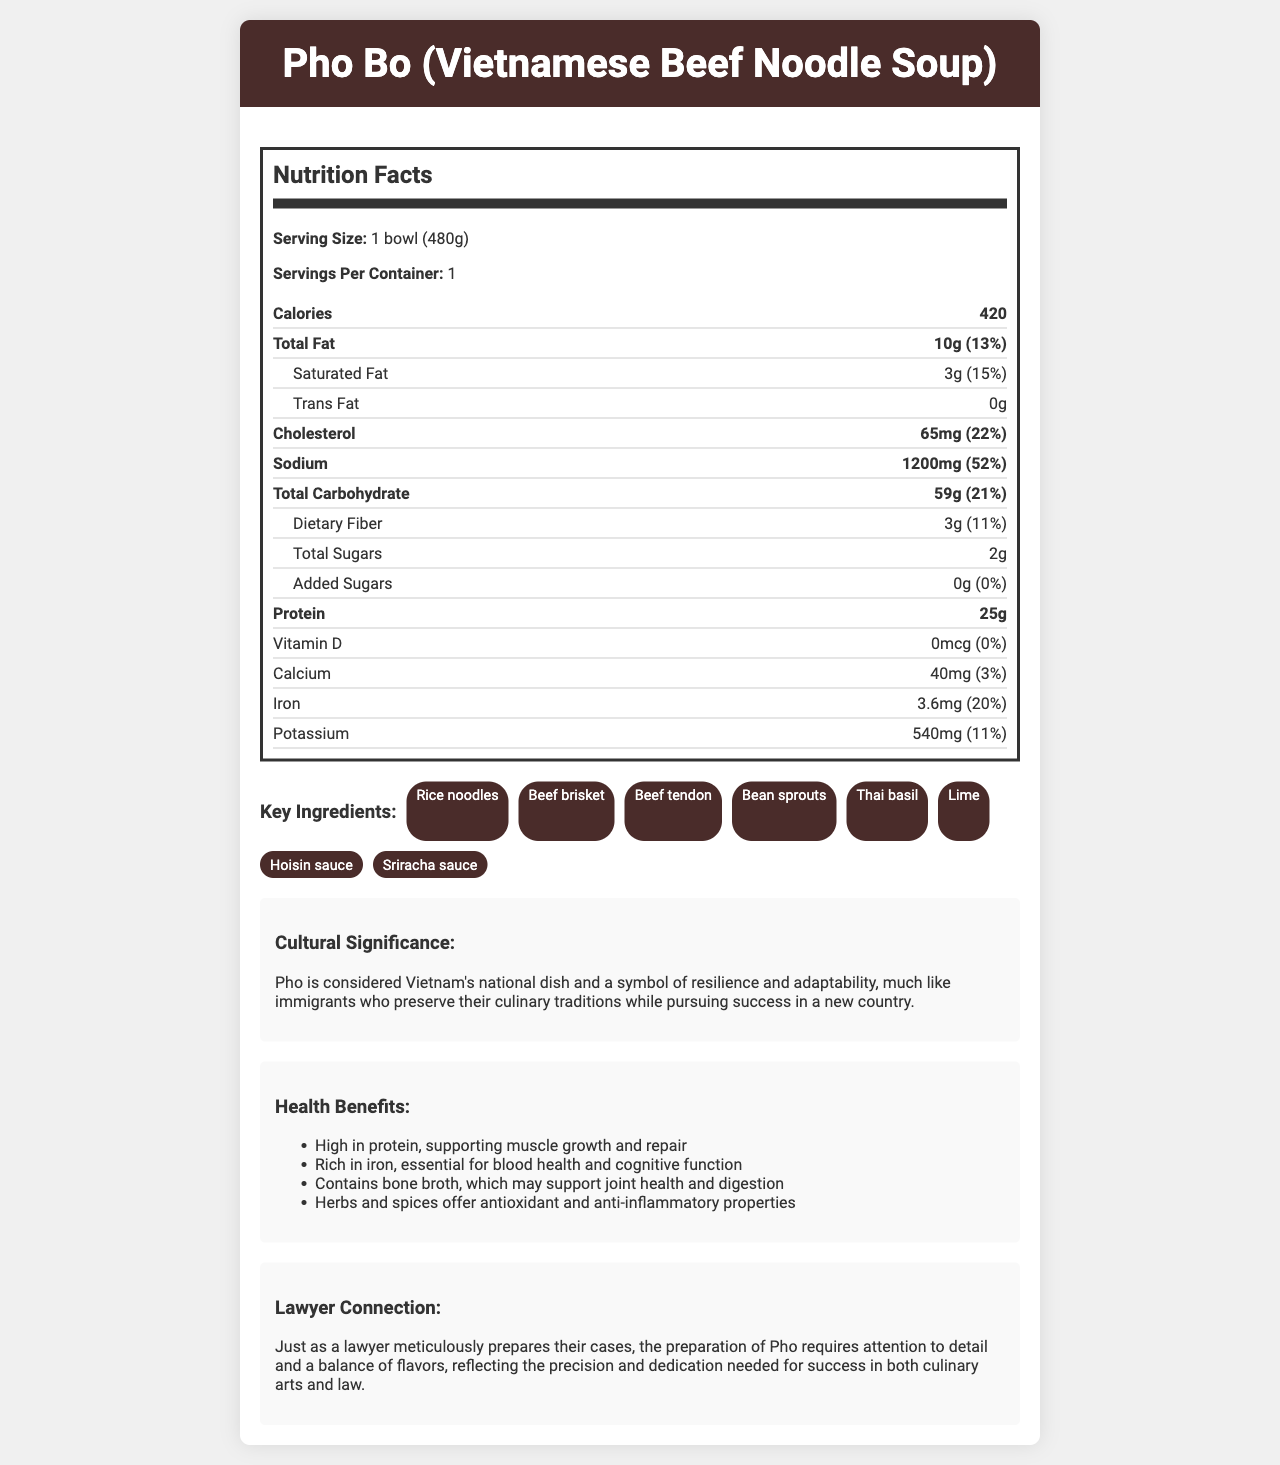what is the serving size of Pho Bo? The serving size is mentioned at the beginning of the Nutrition Facts section in the document.
Answer: 1 bowl (480g) how many calories are in one serving of Pho Bo? The total calorie count is displayed prominently in the nutrition facts.
Answer: 420 what is the daily value percentage of total fat? The total fat amount and its daily percentage value are listed in the Nutrition Facts section.
Answer: 13% how much protein does one serving of Pho Bo contain? The amount of protein per serving is noted in the Nutrition Facts section.
Answer: 25g which ingredients are used in Pho Bo? The list of key ingredients is given in the Ingredients section in the document.
Answer: Rice noodles, Beef brisket, Beef tendon, Bean sprouts, Thai basil, Lime, Hoisin sauce, Sriracha sauce what is the cultural significance of Pho Bo? The cultural significance is explicitly mentioned in the Cultural Significance section.
Answer: Pho is considered Vietnam's national dish and a symbol of resilience and adaptability, much like immigrants who preserve their culinary traditions while pursuing success in a new country. which nutrient has the highest daily value percentage? A. Saturated Fat B. Sodium C. Iron D. Dietary Fiber Sodium has a daily value percentage of 52%, which is the highest among all the listed nutrients.
Answer: B. Sodium how many grams of total carbohydrates are there in one serving? A. 25g B. 59g C. 1200g D. 420g The total carbohydrate content is specified in the Nutrition Facts section and is 59g per serving.
Answer: B. 59g is there any added sugar in Pho Bo? The document explicitly states that there are 0g of added sugars.
Answer: No does Pho Bo contain vitamin D? The document states that there is 0mcg of vitamin D, with a 0% daily value.
Answer: No summarize the main idea of the document. The summary covers the key points of the document: nutritional facts, cultural context, health benefits, and the lawyer connection.
Answer: The document provides detailed nutritional information about Pho Bo, a traditional Vietnamese dish, including its serving size, calorie content, and amounts of various nutrients. It also highlights the cultural significance of Pho Bo, its health benefits, and draws an analogy between the meticulous preparation of Pho Bo and the precision needed in law. what is the total amount of fiber in the dish? The total dietary fiber amount is stated in the Nutrition Facts section.
Answer: 3g what benefit does bone broth offer based on the document? The Health Benefits section lists this as one of the benefits.
Answer: It may support joint health and digestion. how much calcium is in one serving and what is its daily value percentage? The amount of calcium and its daily value percentage are provided in the Nutrition Facts section.
Answer: 40mg, 3% what is the main comparison made between preparing Pho and the work of a lawyer? This comparison is stated in the Lawyer Connection section.
Answer: The preparation of Pho requires attention to detail and a balance of flavors, reflecting the precision and dedication needed for success in both culinary arts and law. what kind of meat is included in Pho Bo? The key ingredients list mentions both beef brisket and beef tendon as part of Pho Bo.
Answer: Beef brisket and Beef tendon what vitamins and minerals are listed in the Nutrition Facts? The vitamins and minerals listed in the Nutrition Facts section include Vitamin D, Calcium, Iron, and Potassium.
Answer: Vitamin D, Calcium, Iron, Potassium what flavor-enhancing ingredients are used in Pho Bo? The key ingredients section lists these two sauces used to enhance the flavor of Pho Bo.
Answer: Hoisin sauce and Sriracha sauce how does the immigrant’s story relate to the cultural significance of Pho Bo? The Cultural Significance section makes this connection explicitly.
Answer: It draws a parallel between the resilience and adaptability of immigrants maintaining their culinary traditions and the symbolism of Pho as a resilient and adaptable dish. how much cholesterol is there in each serving and what is its daily value percentage? The amount of cholesterol and its daily value percentage are provided in the Nutrition Facts section.
Answer: 65mg, 22% does Pho Bo contain any trans fat? The document clearly states that there is 0g trans fat in Pho Bo.
Answer: No which nutrient does Pho Bo provide with a daily value percentage close to that of sodium? None of the other nutrients listed in the document have a daily value percentage close to 52%, the daily value percentage for sodium.
Answer: Cannot be determined 